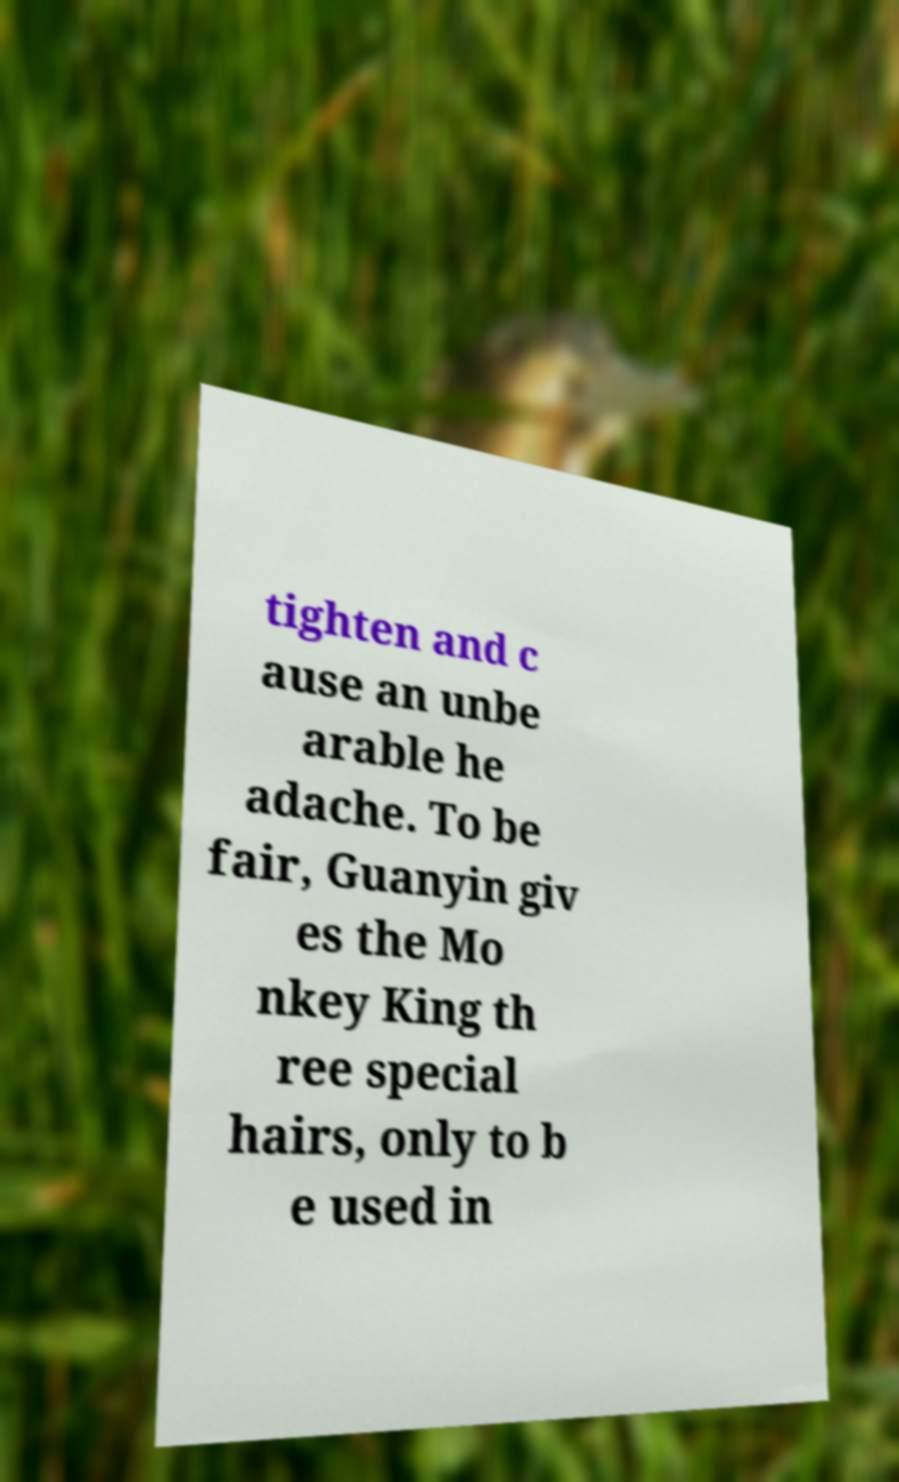Please read and relay the text visible in this image. What does it say? tighten and c ause an unbe arable he adache. To be fair, Guanyin giv es the Mo nkey King th ree special hairs, only to b e used in 